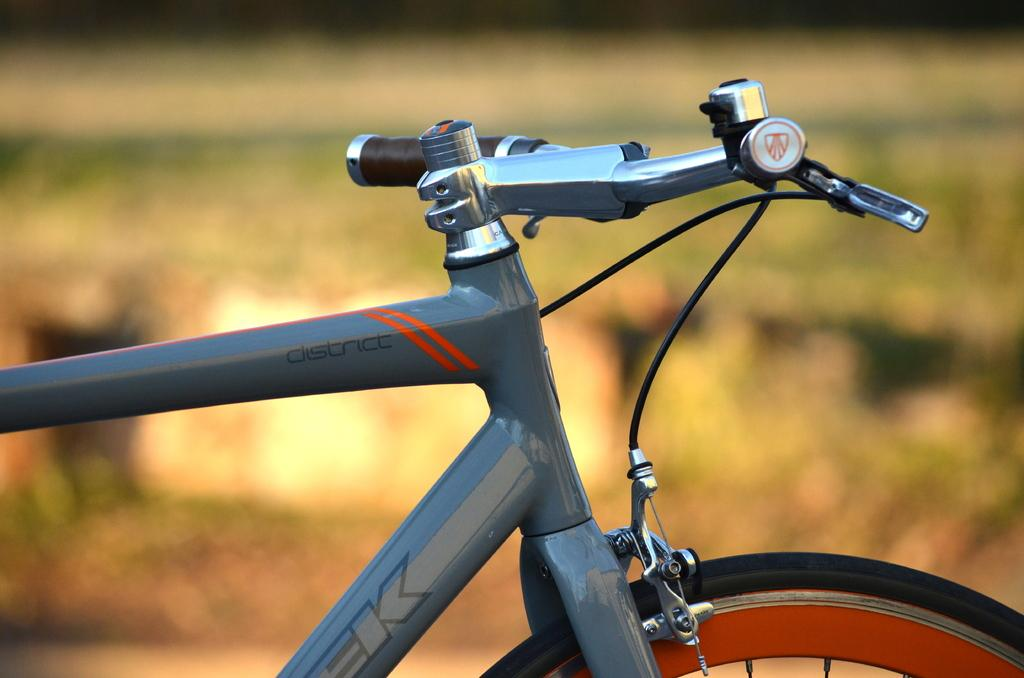What is the main subject of the image? The main subject of the image is a bicycle. Can you describe the background of the image? The background of the image is blurred. Can you tell me how many monkeys are holding the cable in the image? There are no monkeys or cables present in the image; it features a bicycle with a blurred background. 